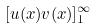<formula> <loc_0><loc_0><loc_500><loc_500>[ u ( x ) v ( x ) ] _ { 1 } ^ { \infty }</formula> 